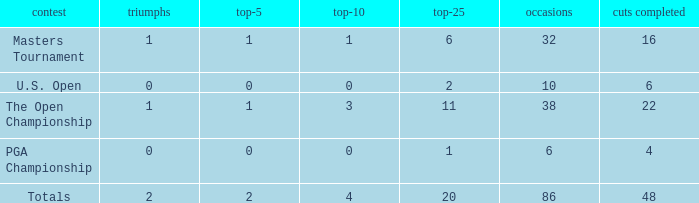Tell me the total number of top 25 for wins less than 1 and cuts made of 22 0.0. 